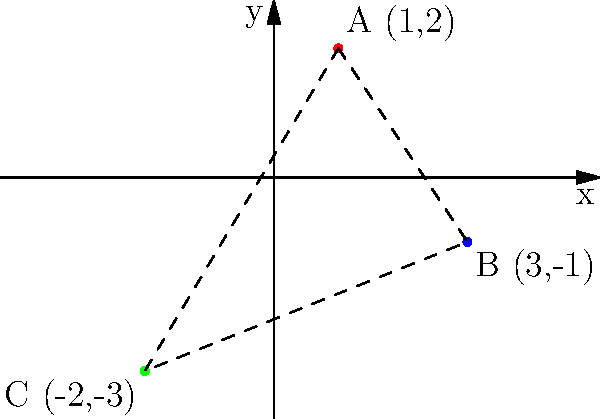As a documentary filmmaker researching Eastern European historical battles, you've plotted three significant battle locations on a coordinate plane. Battle A occurred at (1,2), Battle B at (3,-1), and Battle C at (-2,-3). What is the area of the triangle formed by connecting these three points? To find the area of the triangle formed by the three battle locations, we can use the formula for the area of a triangle given the coordinates of its vertices:

Area = $\frac{1}{2}|x_1(y_2 - y_3) + x_2(y_3 - y_1) + x_3(y_1 - y_2)|$

Where $(x_1, y_1)$, $(x_2, y_2)$, and $(x_3, y_3)$ are the coordinates of the three vertices.

Let's plug in our coordinates:
$(x_1, y_1) = (1, 2)$
$(x_2, y_2) = (3, -1)$
$(x_3, y_3) = (-2, -3)$

Now, let's calculate:

Area = $\frac{1}{2}|1(-1 - (-3)) + 3(-3 - 2) + (-2)(2 - (-1))|$
    = $\frac{1}{2}|1(2) + 3(-5) + (-2)(3)|$
    = $\frac{1}{2}|2 - 15 - 6|$
    = $\frac{1}{2}|-19|$
    = $\frac{1}{2}(19)$
    = $9.5$

Therefore, the area of the triangle formed by the three battle locations is 9.5 square units.
Answer: 9.5 square units 